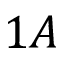Convert formula to latex. <formula><loc_0><loc_0><loc_500><loc_500>1 A</formula> 